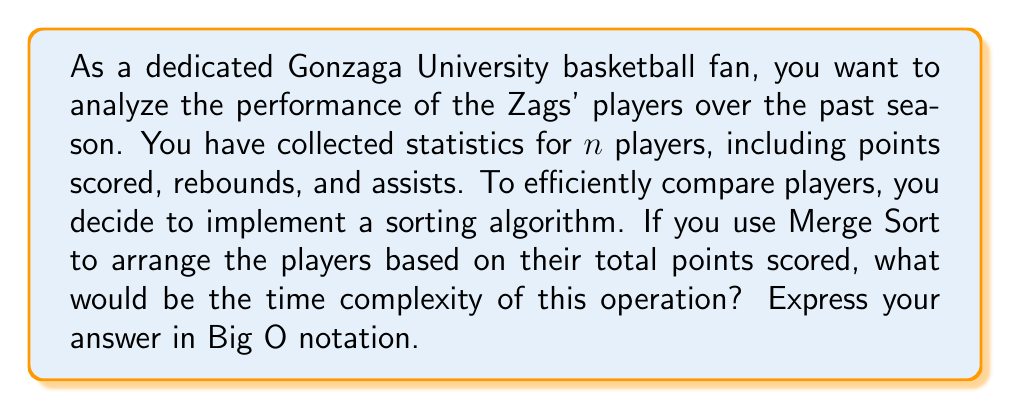Solve this math problem. To solve this problem, let's break down the Merge Sort algorithm and analyze its time complexity:

1. Merge Sort is a divide-and-conquer algorithm that works by recursively dividing the input array into smaller subarrays until each subarray contains only one element.

2. The division process creates a binary tree-like structure, where the height of the tree is $\log_2 n$ (where $n$ is the number of players).

3. At each level of the tree, the algorithm performs a merging operation. The total number of comparisons and movements in the merging step is proportional to the number of elements being merged, which is $n$ at each level.

4. The time complexity can be calculated as follows:
   - Number of levels in the recursion tree: $\log_2 n$
   - Work done at each level: $O(n)$
   - Total time complexity: $O(n \log n)$

5. This time complexity holds for the best, average, and worst-case scenarios of Merge Sort.

6. It's worth noting that Merge Sort has a consistent performance regardless of the initial order of the elements, which is beneficial when dealing with player statistics that may not have any particular pre-existing order.

Therefore, the time complexity of using Merge Sort to arrange the Gonzaga players based on their total points scored would be $O(n \log n)$, where $n$ is the number of players.
Answer: $O(n \log n)$ 